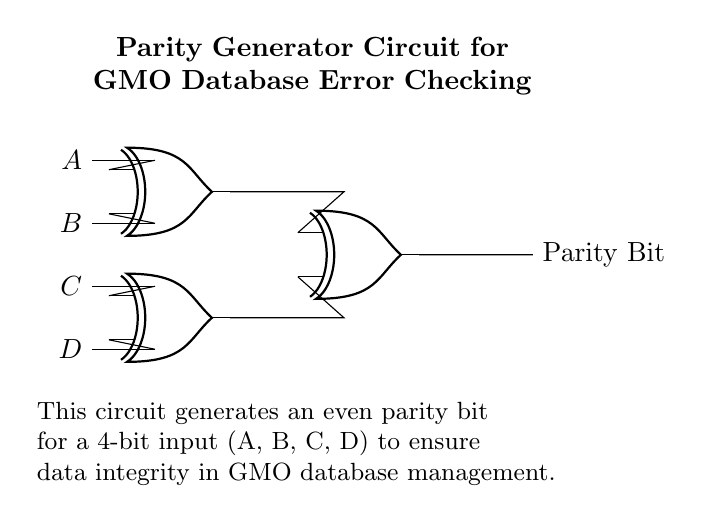What components are used in this circuit? The components in this circuit are four input lines labeled A, B, C, and D, and three XOR gates. The input lines represent the data input for the parity generation, while the XOR gates are the core components used to create the parity bit.
Answer: four input lines and three XOR gates What is the purpose of the parity bit? The purpose of the parity bit is to provide error checking by ensuring that the number of high signals (1s) in the data is even. This helps in maintaining data integrity in the GMO database management system.
Answer: error checking How many input lines does this circuit have? The circuit has four input lines designated as A, B, C, and D. Each of these lines carries a single bit of data, which is processed to generate a single parity bit.
Answer: four How are the outputs of the first two XOR gates connected? The output of the first XOR gate is connected to the input of the third XOR gate, and the output of the second XOR gate is also connected to the third XOR gate. This connection allows the results of the first two XOR operations to be combined to generate the parity bit.
Answer: to the third XOR gate What type of parity does this circuit generate? The circuit generates even parity, which means the output parity bit is set so that the total number of 1s, including the parity bit, is even. This is critical for error detection in digital systems, including databases.
Answer: even parity How does this circuit ensure data integrity? The circuit ensures data integrity by generating a parity bit that helps to check for errors in the data (A, B, C, D) when transmitted or stored. If the number of 1s is not even when the parity bit is added, an error may have occurred.
Answer: by generating a parity bit 